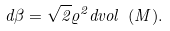Convert formula to latex. <formula><loc_0><loc_0><loc_500><loc_500>d \beta = \sqrt { 2 } \varrho ^ { 2 } d v o l \ ( M ) .</formula> 